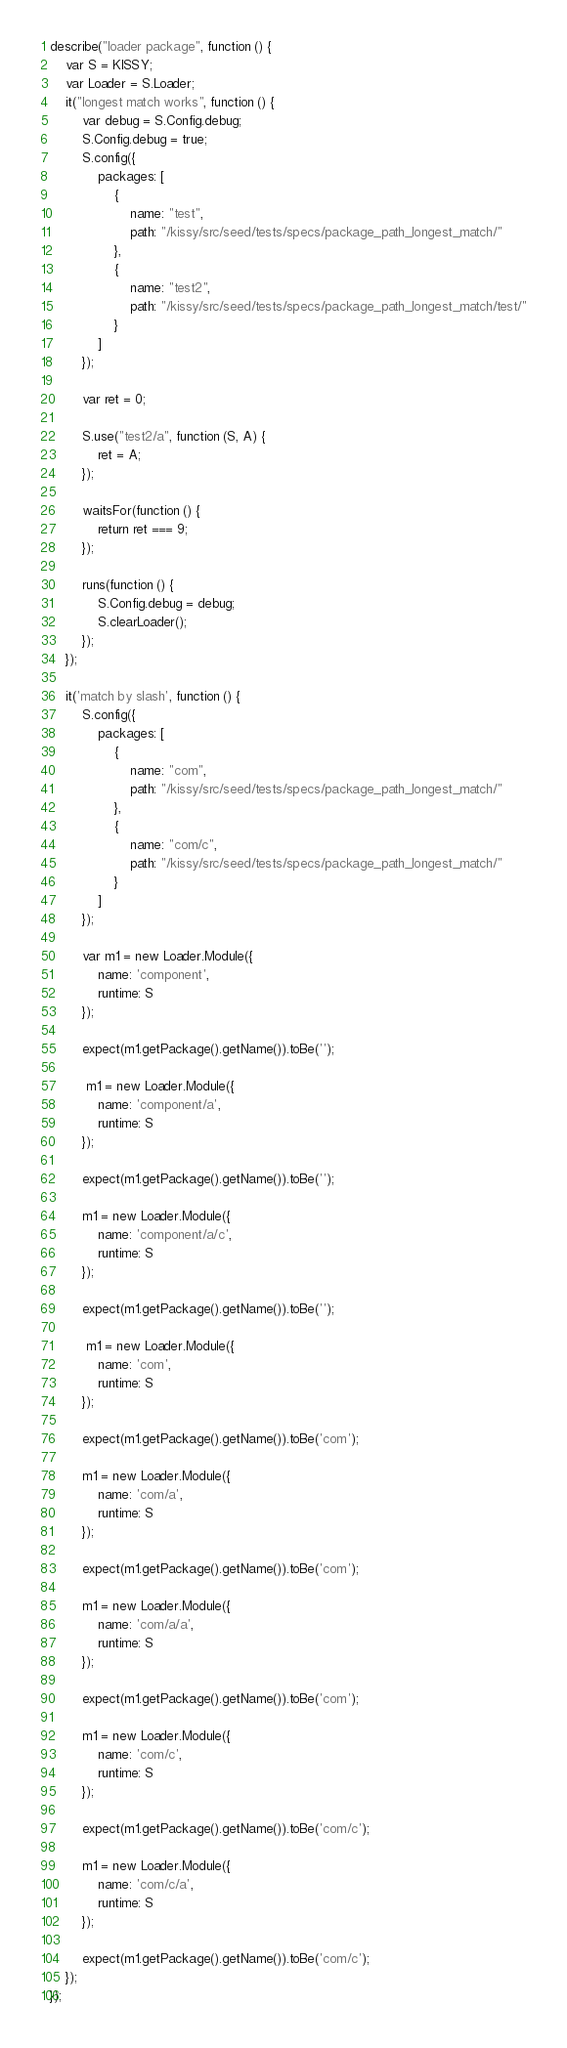<code> <loc_0><loc_0><loc_500><loc_500><_JavaScript_>describe("loader package", function () {
    var S = KISSY;
    var Loader = S.Loader;
    it("longest match works", function () {
        var debug = S.Config.debug;
        S.Config.debug = true;
        S.config({
            packages: [
                {
                    name: "test",
                    path: "/kissy/src/seed/tests/specs/package_path_longest_match/"
                },
                {
                    name: "test2",
                    path: "/kissy/src/seed/tests/specs/package_path_longest_match/test/"
                }
            ]
        });

        var ret = 0;

        S.use("test2/a", function (S, A) {
            ret = A;
        });

        waitsFor(function () {
            return ret === 9;
        });

        runs(function () {
            S.Config.debug = debug;
            S.clearLoader();
        });
    });

    it('match by slash', function () {
        S.config({
            packages: [
                {
                    name: "com",
                    path: "/kissy/src/seed/tests/specs/package_path_longest_match/"
                },
                {
                    name: "com/c",
                    path: "/kissy/src/seed/tests/specs/package_path_longest_match/"
                }
            ]
        });

        var m1 = new Loader.Module({
            name: 'component',
            runtime: S
        });

        expect(m1.getPackage().getName()).toBe('');

         m1 = new Loader.Module({
            name: 'component/a',
            runtime: S
        });

        expect(m1.getPackage().getName()).toBe('');

        m1 = new Loader.Module({
            name: 'component/a/c',
            runtime: S
        });

        expect(m1.getPackage().getName()).toBe('');

         m1 = new Loader.Module({
            name: 'com',
            runtime: S
        });

        expect(m1.getPackage().getName()).toBe('com');

        m1 = new Loader.Module({
            name: 'com/a',
            runtime: S
        });

        expect(m1.getPackage().getName()).toBe('com');

        m1 = new Loader.Module({
            name: 'com/a/a',
            runtime: S
        });

        expect(m1.getPackage().getName()).toBe('com');

        m1 = new Loader.Module({
            name: 'com/c',
            runtime: S
        });

        expect(m1.getPackage().getName()).toBe('com/c');

        m1 = new Loader.Module({
            name: 'com/c/a',
            runtime: S
        });

        expect(m1.getPackage().getName()).toBe('com/c');
    });
});</code> 